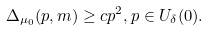<formula> <loc_0><loc_0><loc_500><loc_500>\Delta _ { \mu _ { 0 } } ( p , m ) \geq c p ^ { 2 } , p \in U _ { \delta } ( 0 ) . \\</formula> 